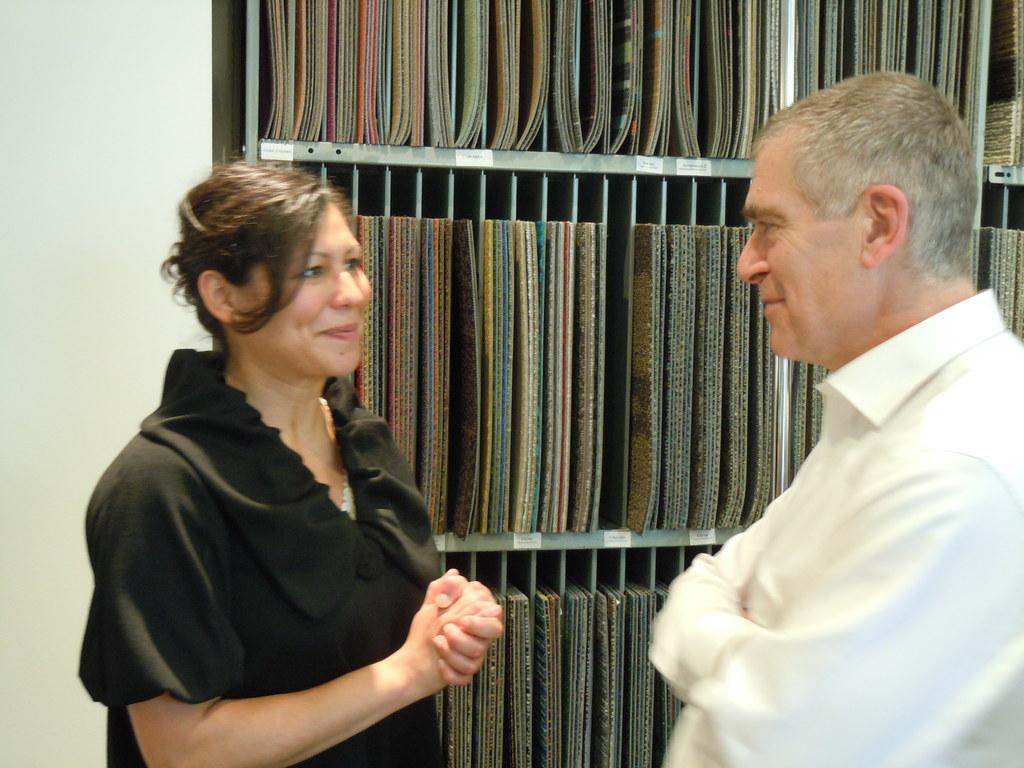What is the emotional expression of the man in the image? The man is smiling in the image. What is the emotional expression of the woman in the image? The woman is also smiling in the image. What color is the dress the woman is wearing? The woman is wearing a black dress. What color is the shirt the man is wearing? The man is wearing a white shirt. What objects can be seen on the metal shelf in the image? There are carpet pieces on a metal shelf in the image. Who is the creator of the test in the image? There is no test present in the image, so it is not possible to determine who the creator might be. 